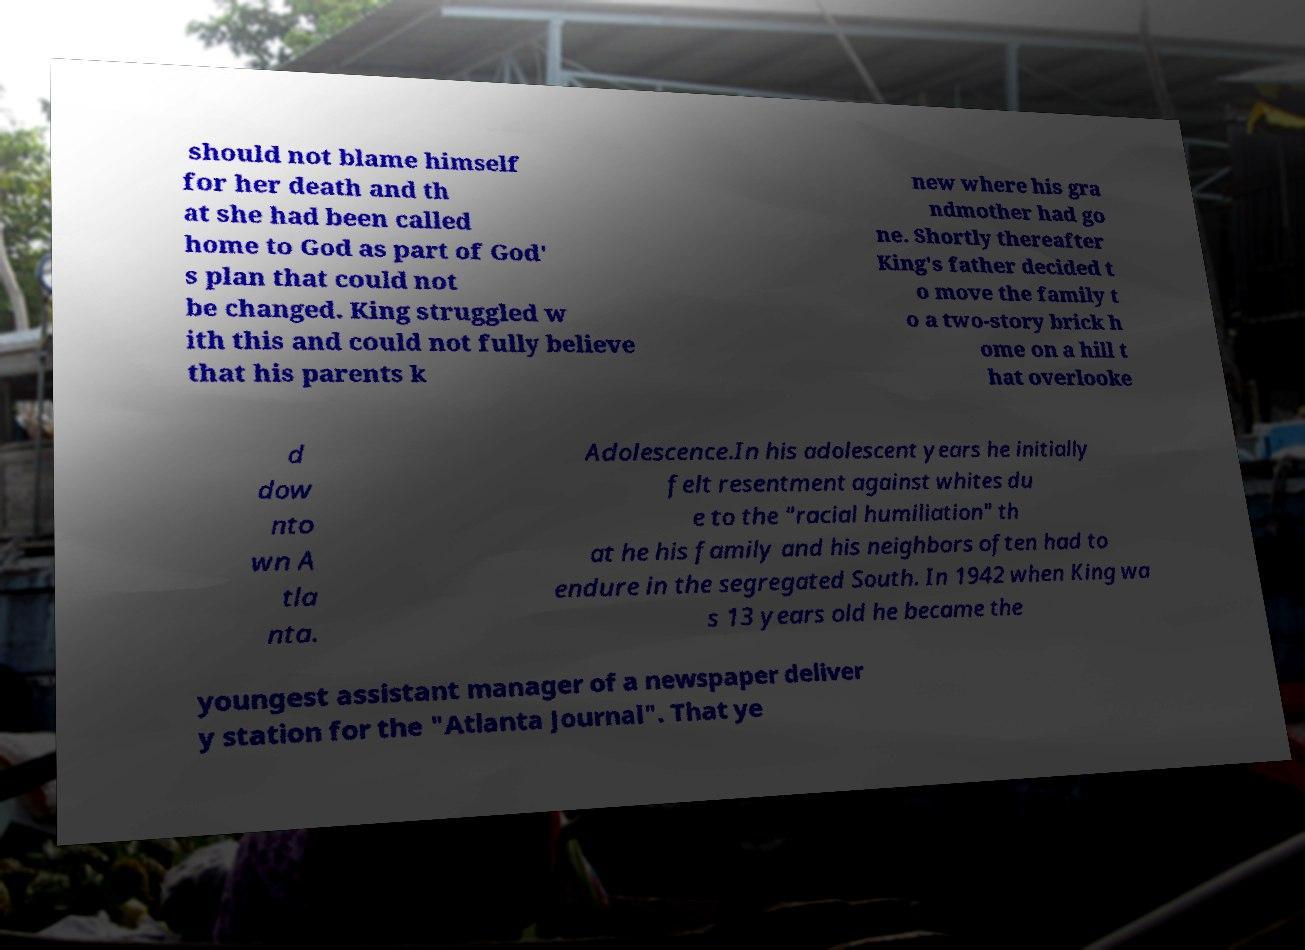For documentation purposes, I need the text within this image transcribed. Could you provide that? should not blame himself for her death and th at she had been called home to God as part of God' s plan that could not be changed. King struggled w ith this and could not fully believe that his parents k new where his gra ndmother had go ne. Shortly thereafter King's father decided t o move the family t o a two-story brick h ome on a hill t hat overlooke d dow nto wn A tla nta. Adolescence.In his adolescent years he initially felt resentment against whites du e to the "racial humiliation" th at he his family and his neighbors often had to endure in the segregated South. In 1942 when King wa s 13 years old he became the youngest assistant manager of a newspaper deliver y station for the "Atlanta Journal". That ye 